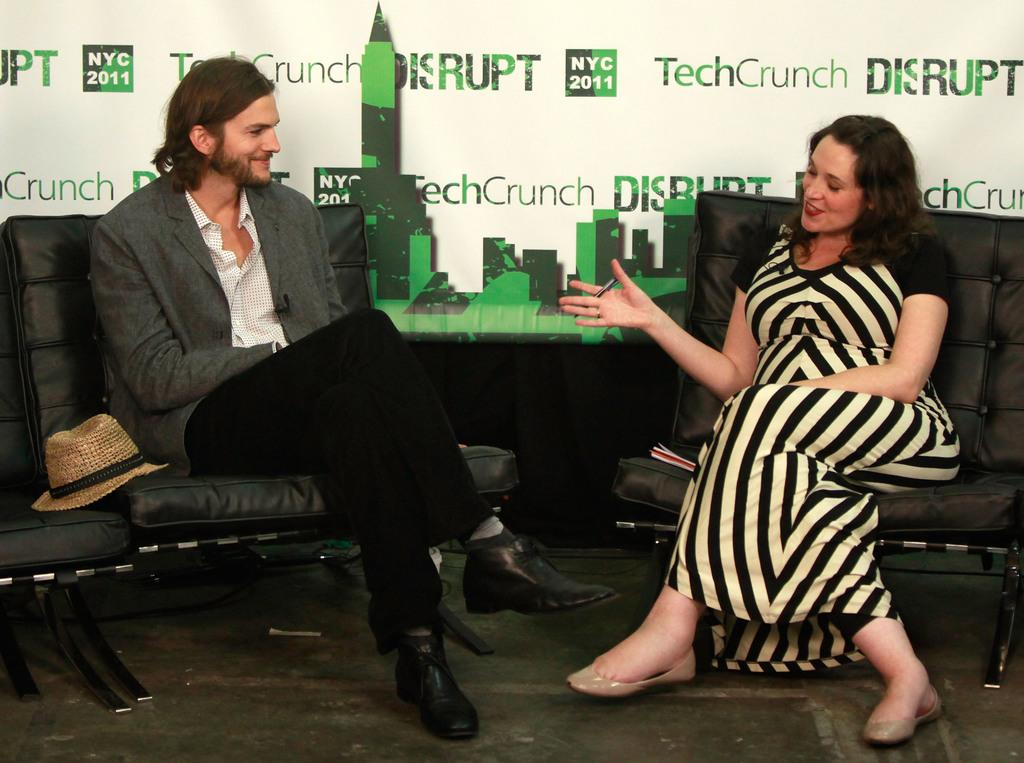How many people are present in the image? There are two people in the image, a man and a woman. What are the man and woman doing in the image? Both the man and woman are sitting on chairs. What can be observed about the background of the image? The background of the image is green and white in color. What invention is being demonstrated by the man and woman in the image? There is no invention being demonstrated in the image; it simply shows a man and woman sitting on chairs. Can you tell me how deep the river is in the image? There is no river present in the image. 